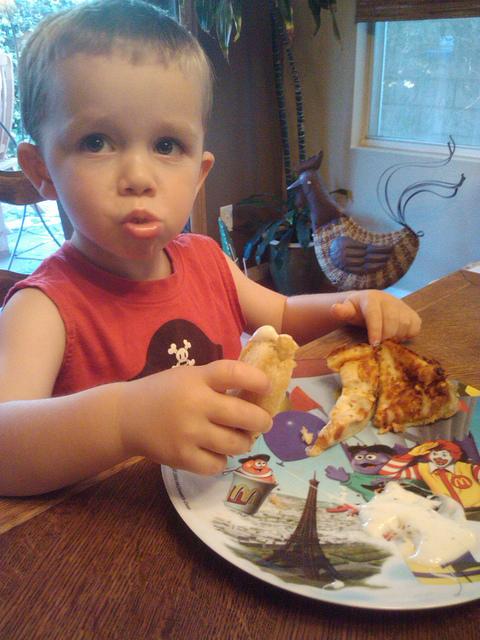What company owns the licensing on the design of the plate?
Quick response, please. Mcdonald's. What is the boy holding?
Be succinct. Pizza. What is the child eating?
Concise answer only. Pizza. What is the boy eating?
Keep it brief. Pizza. 